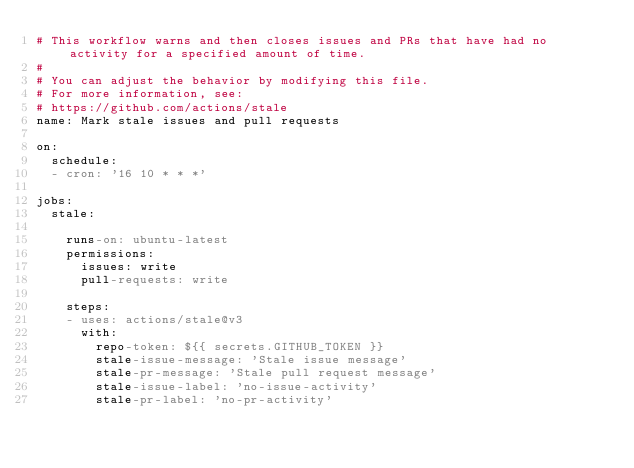Convert code to text. <code><loc_0><loc_0><loc_500><loc_500><_YAML_># This workflow warns and then closes issues and PRs that have had no activity for a specified amount of time.
#
# You can adjust the behavior by modifying this file.
# For more information, see:
# https://github.com/actions/stale
name: Mark stale issues and pull requests

on:
  schedule:
  - cron: '16 10 * * *'

jobs:
  stale:

    runs-on: ubuntu-latest
    permissions:
      issues: write
      pull-requests: write

    steps:
    - uses: actions/stale@v3
      with:
        repo-token: ${{ secrets.GITHUB_TOKEN }}
        stale-issue-message: 'Stale issue message'
        stale-pr-message: 'Stale pull request message'
        stale-issue-label: 'no-issue-activity'
        stale-pr-label: 'no-pr-activity'
</code> 